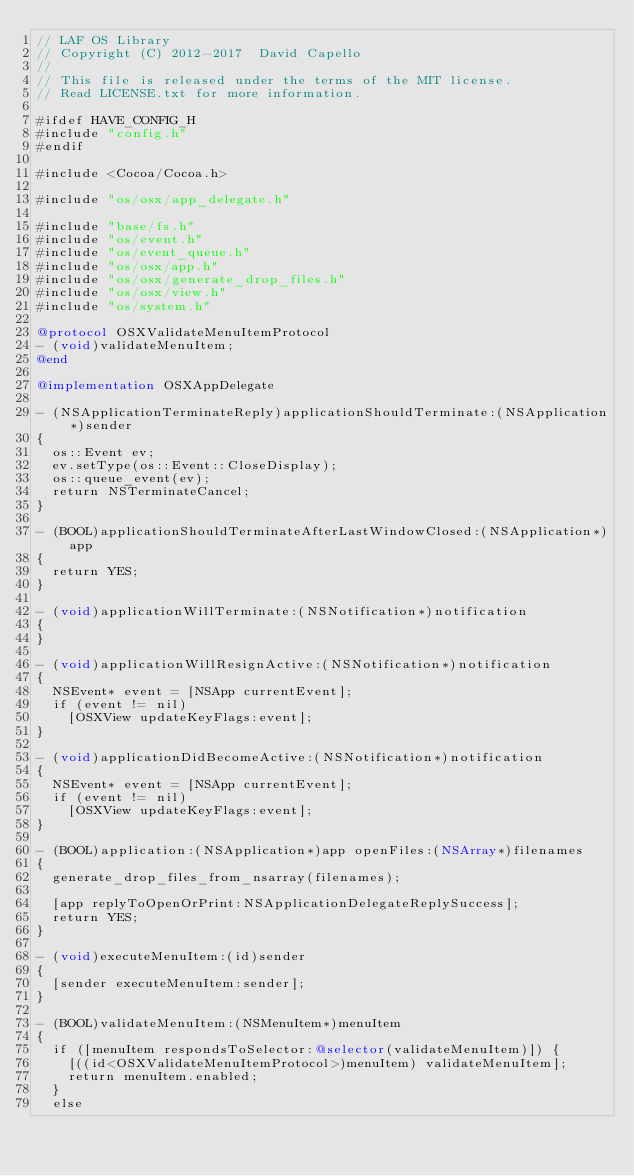<code> <loc_0><loc_0><loc_500><loc_500><_ObjectiveC_>// LAF OS Library
// Copyright (C) 2012-2017  David Capello
//
// This file is released under the terms of the MIT license.
// Read LICENSE.txt for more information.

#ifdef HAVE_CONFIG_H
#include "config.h"
#endif

#include <Cocoa/Cocoa.h>

#include "os/osx/app_delegate.h"

#include "base/fs.h"
#include "os/event.h"
#include "os/event_queue.h"
#include "os/osx/app.h"
#include "os/osx/generate_drop_files.h"
#include "os/osx/view.h"
#include "os/system.h"

@protocol OSXValidateMenuItemProtocol
- (void)validateMenuItem;
@end

@implementation OSXAppDelegate

- (NSApplicationTerminateReply)applicationShouldTerminate:(NSApplication*)sender
{
  os::Event ev;
  ev.setType(os::Event::CloseDisplay);
  os::queue_event(ev);
  return NSTerminateCancel;
}

- (BOOL)applicationShouldTerminateAfterLastWindowClosed:(NSApplication*)app
{
  return YES;
}

- (void)applicationWillTerminate:(NSNotification*)notification
{
}

- (void)applicationWillResignActive:(NSNotification*)notification
{
  NSEvent* event = [NSApp currentEvent];
  if (event != nil)
    [OSXView updateKeyFlags:event];
}

- (void)applicationDidBecomeActive:(NSNotification*)notification
{
  NSEvent* event = [NSApp currentEvent];
  if (event != nil)
    [OSXView updateKeyFlags:event];
}

- (BOOL)application:(NSApplication*)app openFiles:(NSArray*)filenames
{
  generate_drop_files_from_nsarray(filenames);

  [app replyToOpenOrPrint:NSApplicationDelegateReplySuccess];
  return YES;
}

- (void)executeMenuItem:(id)sender
{
  [sender executeMenuItem:sender];
}

- (BOOL)validateMenuItem:(NSMenuItem*)menuItem
{
  if ([menuItem respondsToSelector:@selector(validateMenuItem)]) {
    [((id<OSXValidateMenuItemProtocol>)menuItem) validateMenuItem];
    return menuItem.enabled;
  }
  else</code> 